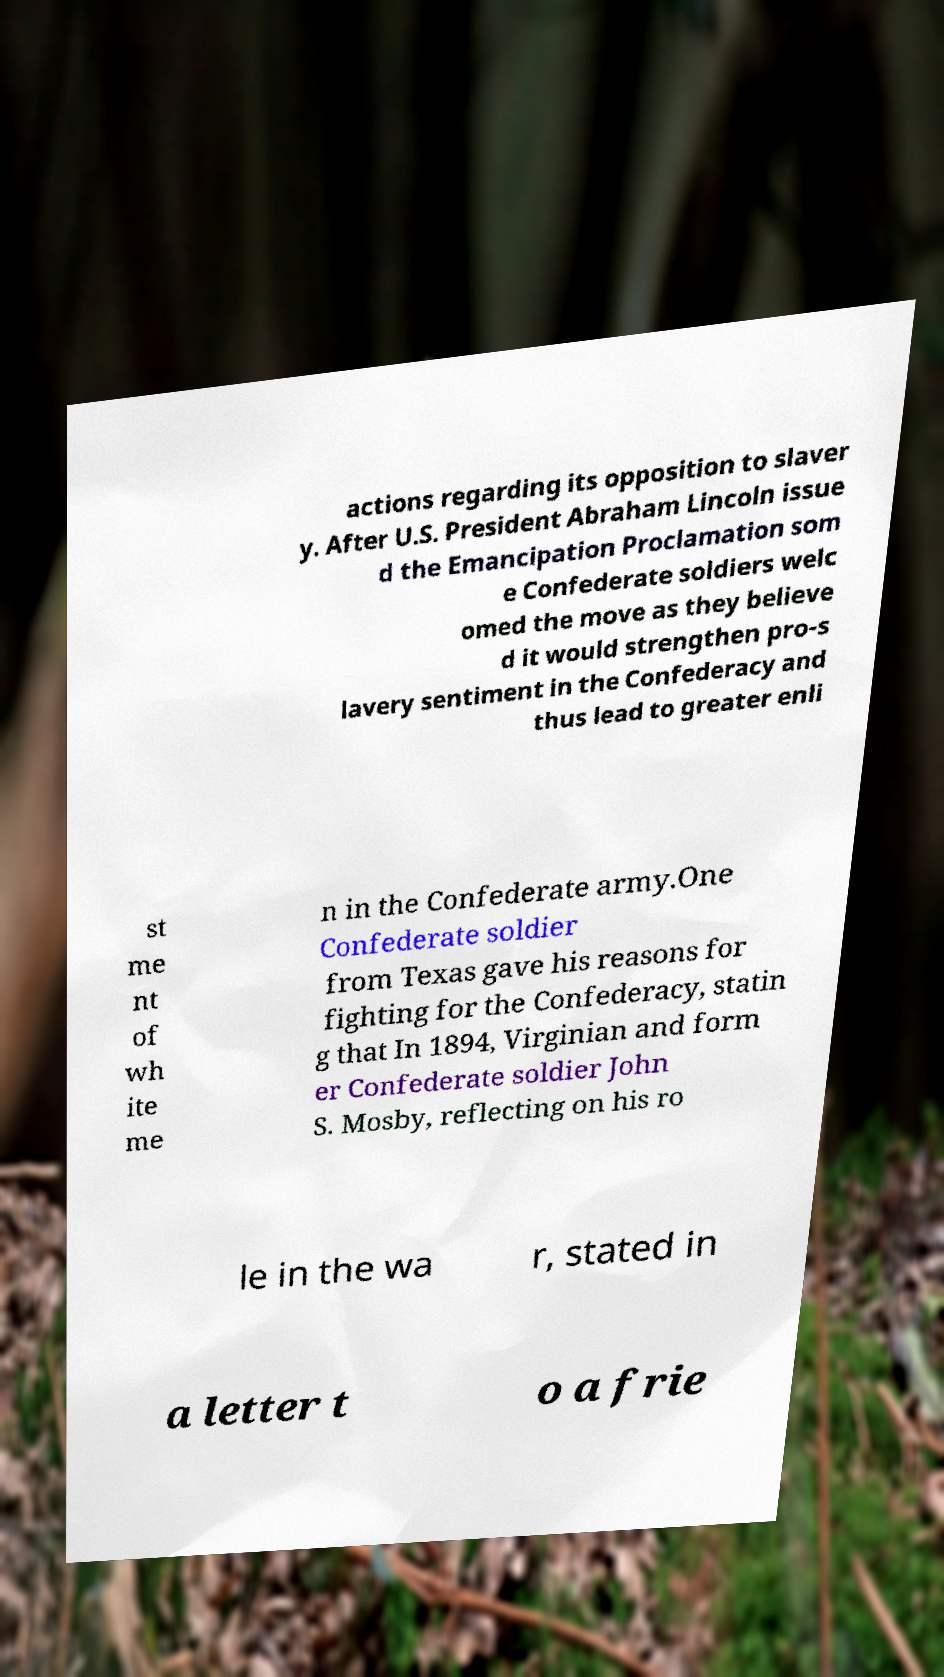There's text embedded in this image that I need extracted. Can you transcribe it verbatim? actions regarding its opposition to slaver y. After U.S. President Abraham Lincoln issue d the Emancipation Proclamation som e Confederate soldiers welc omed the move as they believe d it would strengthen pro-s lavery sentiment in the Confederacy and thus lead to greater enli st me nt of wh ite me n in the Confederate army.One Confederate soldier from Texas gave his reasons for fighting for the Confederacy, statin g that In 1894, Virginian and form er Confederate soldier John S. Mosby, reflecting on his ro le in the wa r, stated in a letter t o a frie 